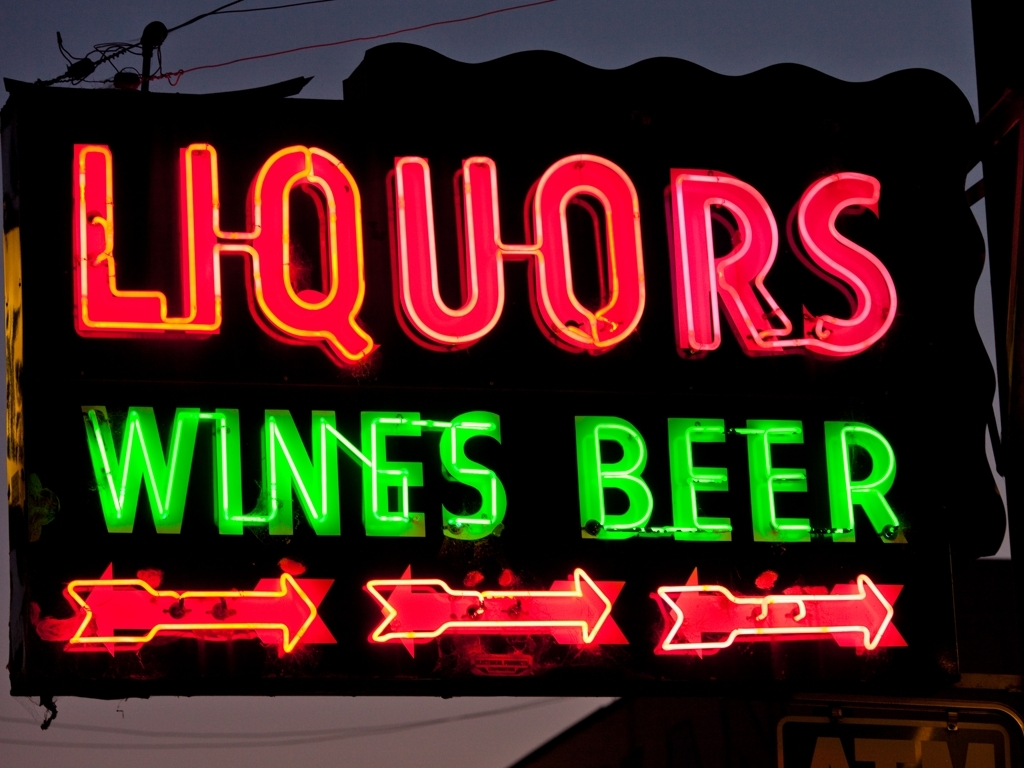Are there any quality issues with this image? Yes, there are several quality issues with this image: the lighting conditions appear to cause reflections and glare, making certain parts of the neon sign difficult to read clearly. Additionally, there's visible wear and tear on the sign, which might indicate it's quite old or has not been well-maintained. 